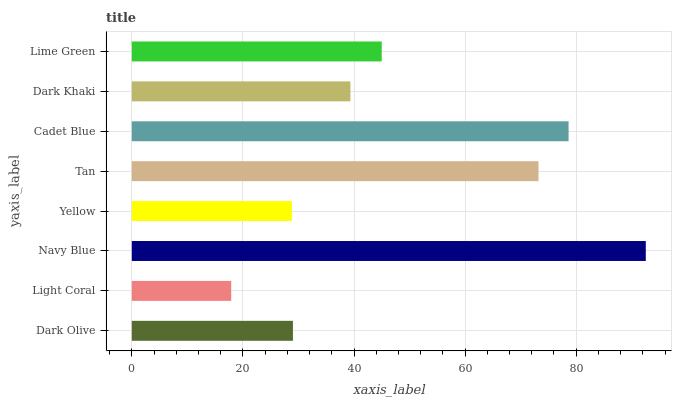Is Light Coral the minimum?
Answer yes or no. Yes. Is Navy Blue the maximum?
Answer yes or no. Yes. Is Navy Blue the minimum?
Answer yes or no. No. Is Light Coral the maximum?
Answer yes or no. No. Is Navy Blue greater than Light Coral?
Answer yes or no. Yes. Is Light Coral less than Navy Blue?
Answer yes or no. Yes. Is Light Coral greater than Navy Blue?
Answer yes or no. No. Is Navy Blue less than Light Coral?
Answer yes or no. No. Is Lime Green the high median?
Answer yes or no. Yes. Is Dark Khaki the low median?
Answer yes or no. Yes. Is Dark Khaki the high median?
Answer yes or no. No. Is Light Coral the low median?
Answer yes or no. No. 